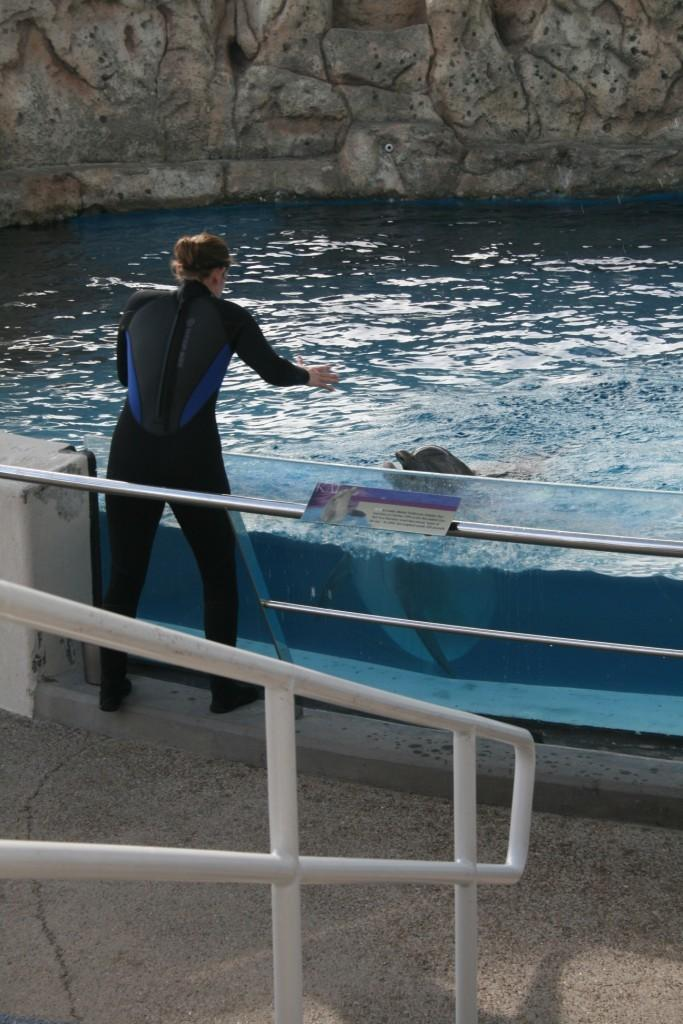What is the main subject of the image? There is a person standing in the image. What objects can be seen in the image besides the person? There are rods, glass, a poster, and water visible in the image. What is the person standing near in the image? The person is standing near water in the image. What animal can be seen in the water? There is a dolphin in the water. What type of background is visible in the image? There are rocks in the background of the image. How many servants are attending to the crowd in the image? There is no crowd or servants present in the image. What type of sheet is covering the dolphin in the image? There is no sheet covering the dolphin in the image; it is swimming freely in the water. 